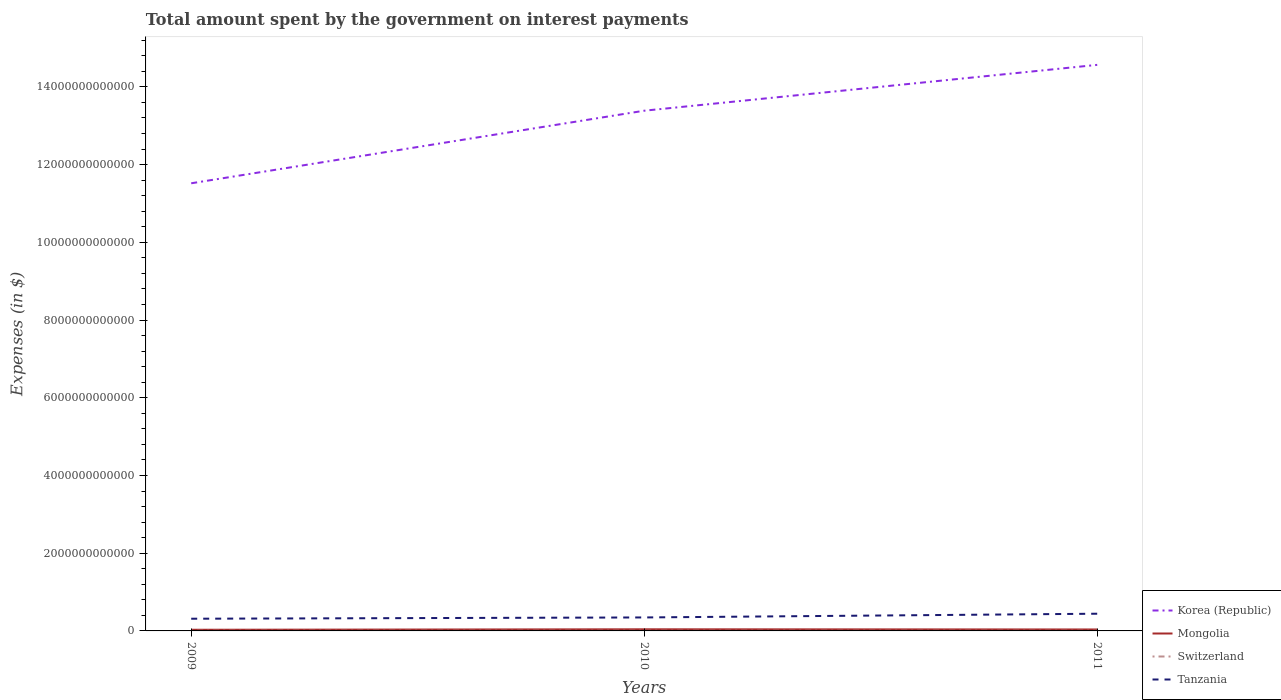Across all years, what is the maximum amount spent on interest payments by the government in Switzerland?
Ensure brevity in your answer.  3.12e+09. In which year was the amount spent on interest payments by the government in Tanzania maximum?
Offer a terse response. 2009. What is the total amount spent on interest payments by the government in Switzerland in the graph?
Ensure brevity in your answer.  1.58e+08. What is the difference between the highest and the second highest amount spent on interest payments by the government in Switzerland?
Provide a succinct answer. 1.66e+08. What is the difference between the highest and the lowest amount spent on interest payments by the government in Tanzania?
Make the answer very short. 1. Is the amount spent on interest payments by the government in Mongolia strictly greater than the amount spent on interest payments by the government in Tanzania over the years?
Your answer should be very brief. Yes. What is the difference between two consecutive major ticks on the Y-axis?
Offer a very short reply. 2.00e+12. Does the graph contain any zero values?
Offer a terse response. No. Does the graph contain grids?
Your answer should be compact. No. Where does the legend appear in the graph?
Your answer should be compact. Bottom right. What is the title of the graph?
Ensure brevity in your answer.  Total amount spent by the government on interest payments. What is the label or title of the X-axis?
Offer a terse response. Years. What is the label or title of the Y-axis?
Keep it short and to the point. Expenses (in $). What is the Expenses (in $) in Korea (Republic) in 2009?
Your answer should be compact. 1.15e+13. What is the Expenses (in $) in Mongolia in 2009?
Your answer should be very brief. 2.96e+1. What is the Expenses (in $) of Switzerland in 2009?
Make the answer very short. 3.28e+09. What is the Expenses (in $) in Tanzania in 2009?
Make the answer very short. 3.14e+11. What is the Expenses (in $) of Korea (Republic) in 2010?
Ensure brevity in your answer.  1.34e+13. What is the Expenses (in $) in Mongolia in 2010?
Offer a terse response. 4.19e+1. What is the Expenses (in $) of Switzerland in 2010?
Offer a terse response. 3.12e+09. What is the Expenses (in $) of Tanzania in 2010?
Offer a terse response. 3.47e+11. What is the Expenses (in $) in Korea (Republic) in 2011?
Keep it short and to the point. 1.46e+13. What is the Expenses (in $) of Mongolia in 2011?
Provide a short and direct response. 3.73e+1. What is the Expenses (in $) of Switzerland in 2011?
Provide a succinct answer. 3.29e+09. What is the Expenses (in $) of Tanzania in 2011?
Ensure brevity in your answer.  4.43e+11. Across all years, what is the maximum Expenses (in $) in Korea (Republic)?
Offer a terse response. 1.46e+13. Across all years, what is the maximum Expenses (in $) in Mongolia?
Offer a terse response. 4.19e+1. Across all years, what is the maximum Expenses (in $) of Switzerland?
Your answer should be compact. 3.29e+09. Across all years, what is the maximum Expenses (in $) in Tanzania?
Keep it short and to the point. 4.43e+11. Across all years, what is the minimum Expenses (in $) of Korea (Republic)?
Provide a short and direct response. 1.15e+13. Across all years, what is the minimum Expenses (in $) of Mongolia?
Keep it short and to the point. 2.96e+1. Across all years, what is the minimum Expenses (in $) of Switzerland?
Ensure brevity in your answer.  3.12e+09. Across all years, what is the minimum Expenses (in $) of Tanzania?
Give a very brief answer. 3.14e+11. What is the total Expenses (in $) of Korea (Republic) in the graph?
Provide a short and direct response. 3.95e+13. What is the total Expenses (in $) of Mongolia in the graph?
Provide a succinct answer. 1.09e+11. What is the total Expenses (in $) in Switzerland in the graph?
Offer a very short reply. 9.69e+09. What is the total Expenses (in $) of Tanzania in the graph?
Your answer should be very brief. 1.10e+12. What is the difference between the Expenses (in $) of Korea (Republic) in 2009 and that in 2010?
Make the answer very short. -1.87e+12. What is the difference between the Expenses (in $) of Mongolia in 2009 and that in 2010?
Give a very brief answer. -1.23e+1. What is the difference between the Expenses (in $) of Switzerland in 2009 and that in 2010?
Provide a short and direct response. 1.58e+08. What is the difference between the Expenses (in $) in Tanzania in 2009 and that in 2010?
Offer a very short reply. -3.27e+1. What is the difference between the Expenses (in $) in Korea (Republic) in 2009 and that in 2011?
Your response must be concise. -3.05e+12. What is the difference between the Expenses (in $) of Mongolia in 2009 and that in 2011?
Ensure brevity in your answer.  -7.70e+09. What is the difference between the Expenses (in $) of Switzerland in 2009 and that in 2011?
Give a very brief answer. -8.26e+06. What is the difference between the Expenses (in $) of Tanzania in 2009 and that in 2011?
Give a very brief answer. -1.29e+11. What is the difference between the Expenses (in $) in Korea (Republic) in 2010 and that in 2011?
Make the answer very short. -1.18e+12. What is the difference between the Expenses (in $) of Mongolia in 2010 and that in 2011?
Provide a succinct answer. 4.60e+09. What is the difference between the Expenses (in $) in Switzerland in 2010 and that in 2011?
Your answer should be compact. -1.66e+08. What is the difference between the Expenses (in $) of Tanzania in 2010 and that in 2011?
Provide a succinct answer. -9.59e+1. What is the difference between the Expenses (in $) of Korea (Republic) in 2009 and the Expenses (in $) of Mongolia in 2010?
Your answer should be very brief. 1.15e+13. What is the difference between the Expenses (in $) of Korea (Republic) in 2009 and the Expenses (in $) of Switzerland in 2010?
Your answer should be compact. 1.15e+13. What is the difference between the Expenses (in $) in Korea (Republic) in 2009 and the Expenses (in $) in Tanzania in 2010?
Provide a succinct answer. 1.12e+13. What is the difference between the Expenses (in $) in Mongolia in 2009 and the Expenses (in $) in Switzerland in 2010?
Make the answer very short. 2.65e+1. What is the difference between the Expenses (in $) of Mongolia in 2009 and the Expenses (in $) of Tanzania in 2010?
Your answer should be very brief. -3.17e+11. What is the difference between the Expenses (in $) in Switzerland in 2009 and the Expenses (in $) in Tanzania in 2010?
Offer a very short reply. -3.43e+11. What is the difference between the Expenses (in $) of Korea (Republic) in 2009 and the Expenses (in $) of Mongolia in 2011?
Make the answer very short. 1.15e+13. What is the difference between the Expenses (in $) in Korea (Republic) in 2009 and the Expenses (in $) in Switzerland in 2011?
Your response must be concise. 1.15e+13. What is the difference between the Expenses (in $) of Korea (Republic) in 2009 and the Expenses (in $) of Tanzania in 2011?
Give a very brief answer. 1.11e+13. What is the difference between the Expenses (in $) of Mongolia in 2009 and the Expenses (in $) of Switzerland in 2011?
Provide a short and direct response. 2.63e+1. What is the difference between the Expenses (in $) in Mongolia in 2009 and the Expenses (in $) in Tanzania in 2011?
Provide a short and direct response. -4.13e+11. What is the difference between the Expenses (in $) of Switzerland in 2009 and the Expenses (in $) of Tanzania in 2011?
Give a very brief answer. -4.39e+11. What is the difference between the Expenses (in $) of Korea (Republic) in 2010 and the Expenses (in $) of Mongolia in 2011?
Your answer should be very brief. 1.33e+13. What is the difference between the Expenses (in $) of Korea (Republic) in 2010 and the Expenses (in $) of Switzerland in 2011?
Make the answer very short. 1.34e+13. What is the difference between the Expenses (in $) in Korea (Republic) in 2010 and the Expenses (in $) in Tanzania in 2011?
Your answer should be very brief. 1.29e+13. What is the difference between the Expenses (in $) of Mongolia in 2010 and the Expenses (in $) of Switzerland in 2011?
Offer a terse response. 3.86e+1. What is the difference between the Expenses (in $) in Mongolia in 2010 and the Expenses (in $) in Tanzania in 2011?
Your answer should be compact. -4.01e+11. What is the difference between the Expenses (in $) in Switzerland in 2010 and the Expenses (in $) in Tanzania in 2011?
Ensure brevity in your answer.  -4.40e+11. What is the average Expenses (in $) in Korea (Republic) per year?
Keep it short and to the point. 1.32e+13. What is the average Expenses (in $) in Mongolia per year?
Provide a succinct answer. 3.63e+1. What is the average Expenses (in $) of Switzerland per year?
Provide a succinct answer. 3.23e+09. What is the average Expenses (in $) in Tanzania per year?
Provide a succinct answer. 3.68e+11. In the year 2009, what is the difference between the Expenses (in $) of Korea (Republic) and Expenses (in $) of Mongolia?
Your answer should be compact. 1.15e+13. In the year 2009, what is the difference between the Expenses (in $) in Korea (Republic) and Expenses (in $) in Switzerland?
Provide a short and direct response. 1.15e+13. In the year 2009, what is the difference between the Expenses (in $) in Korea (Republic) and Expenses (in $) in Tanzania?
Provide a short and direct response. 1.12e+13. In the year 2009, what is the difference between the Expenses (in $) of Mongolia and Expenses (in $) of Switzerland?
Provide a short and direct response. 2.63e+1. In the year 2009, what is the difference between the Expenses (in $) in Mongolia and Expenses (in $) in Tanzania?
Your answer should be compact. -2.84e+11. In the year 2009, what is the difference between the Expenses (in $) of Switzerland and Expenses (in $) of Tanzania?
Ensure brevity in your answer.  -3.11e+11. In the year 2010, what is the difference between the Expenses (in $) in Korea (Republic) and Expenses (in $) in Mongolia?
Make the answer very short. 1.33e+13. In the year 2010, what is the difference between the Expenses (in $) in Korea (Republic) and Expenses (in $) in Switzerland?
Your answer should be very brief. 1.34e+13. In the year 2010, what is the difference between the Expenses (in $) in Korea (Republic) and Expenses (in $) in Tanzania?
Provide a short and direct response. 1.30e+13. In the year 2010, what is the difference between the Expenses (in $) in Mongolia and Expenses (in $) in Switzerland?
Make the answer very short. 3.88e+1. In the year 2010, what is the difference between the Expenses (in $) of Mongolia and Expenses (in $) of Tanzania?
Make the answer very short. -3.05e+11. In the year 2010, what is the difference between the Expenses (in $) in Switzerland and Expenses (in $) in Tanzania?
Your answer should be very brief. -3.44e+11. In the year 2011, what is the difference between the Expenses (in $) in Korea (Republic) and Expenses (in $) in Mongolia?
Offer a very short reply. 1.45e+13. In the year 2011, what is the difference between the Expenses (in $) in Korea (Republic) and Expenses (in $) in Switzerland?
Your answer should be compact. 1.46e+13. In the year 2011, what is the difference between the Expenses (in $) in Korea (Republic) and Expenses (in $) in Tanzania?
Offer a very short reply. 1.41e+13. In the year 2011, what is the difference between the Expenses (in $) of Mongolia and Expenses (in $) of Switzerland?
Make the answer very short. 3.40e+1. In the year 2011, what is the difference between the Expenses (in $) in Mongolia and Expenses (in $) in Tanzania?
Your response must be concise. -4.05e+11. In the year 2011, what is the difference between the Expenses (in $) in Switzerland and Expenses (in $) in Tanzania?
Make the answer very short. -4.39e+11. What is the ratio of the Expenses (in $) in Korea (Republic) in 2009 to that in 2010?
Your response must be concise. 0.86. What is the ratio of the Expenses (in $) of Mongolia in 2009 to that in 2010?
Make the answer very short. 0.71. What is the ratio of the Expenses (in $) of Switzerland in 2009 to that in 2010?
Give a very brief answer. 1.05. What is the ratio of the Expenses (in $) of Tanzania in 2009 to that in 2010?
Provide a succinct answer. 0.91. What is the ratio of the Expenses (in $) of Korea (Republic) in 2009 to that in 2011?
Keep it short and to the point. 0.79. What is the ratio of the Expenses (in $) of Mongolia in 2009 to that in 2011?
Your answer should be very brief. 0.79. What is the ratio of the Expenses (in $) in Switzerland in 2009 to that in 2011?
Offer a very short reply. 1. What is the ratio of the Expenses (in $) of Tanzania in 2009 to that in 2011?
Keep it short and to the point. 0.71. What is the ratio of the Expenses (in $) of Korea (Republic) in 2010 to that in 2011?
Your answer should be very brief. 0.92. What is the ratio of the Expenses (in $) of Mongolia in 2010 to that in 2011?
Your response must be concise. 1.12. What is the ratio of the Expenses (in $) of Switzerland in 2010 to that in 2011?
Your answer should be compact. 0.95. What is the ratio of the Expenses (in $) in Tanzania in 2010 to that in 2011?
Provide a short and direct response. 0.78. What is the difference between the highest and the second highest Expenses (in $) in Korea (Republic)?
Ensure brevity in your answer.  1.18e+12. What is the difference between the highest and the second highest Expenses (in $) in Mongolia?
Make the answer very short. 4.60e+09. What is the difference between the highest and the second highest Expenses (in $) in Switzerland?
Your answer should be very brief. 8.26e+06. What is the difference between the highest and the second highest Expenses (in $) of Tanzania?
Offer a terse response. 9.59e+1. What is the difference between the highest and the lowest Expenses (in $) of Korea (Republic)?
Ensure brevity in your answer.  3.05e+12. What is the difference between the highest and the lowest Expenses (in $) in Mongolia?
Your answer should be compact. 1.23e+1. What is the difference between the highest and the lowest Expenses (in $) in Switzerland?
Make the answer very short. 1.66e+08. What is the difference between the highest and the lowest Expenses (in $) in Tanzania?
Give a very brief answer. 1.29e+11. 